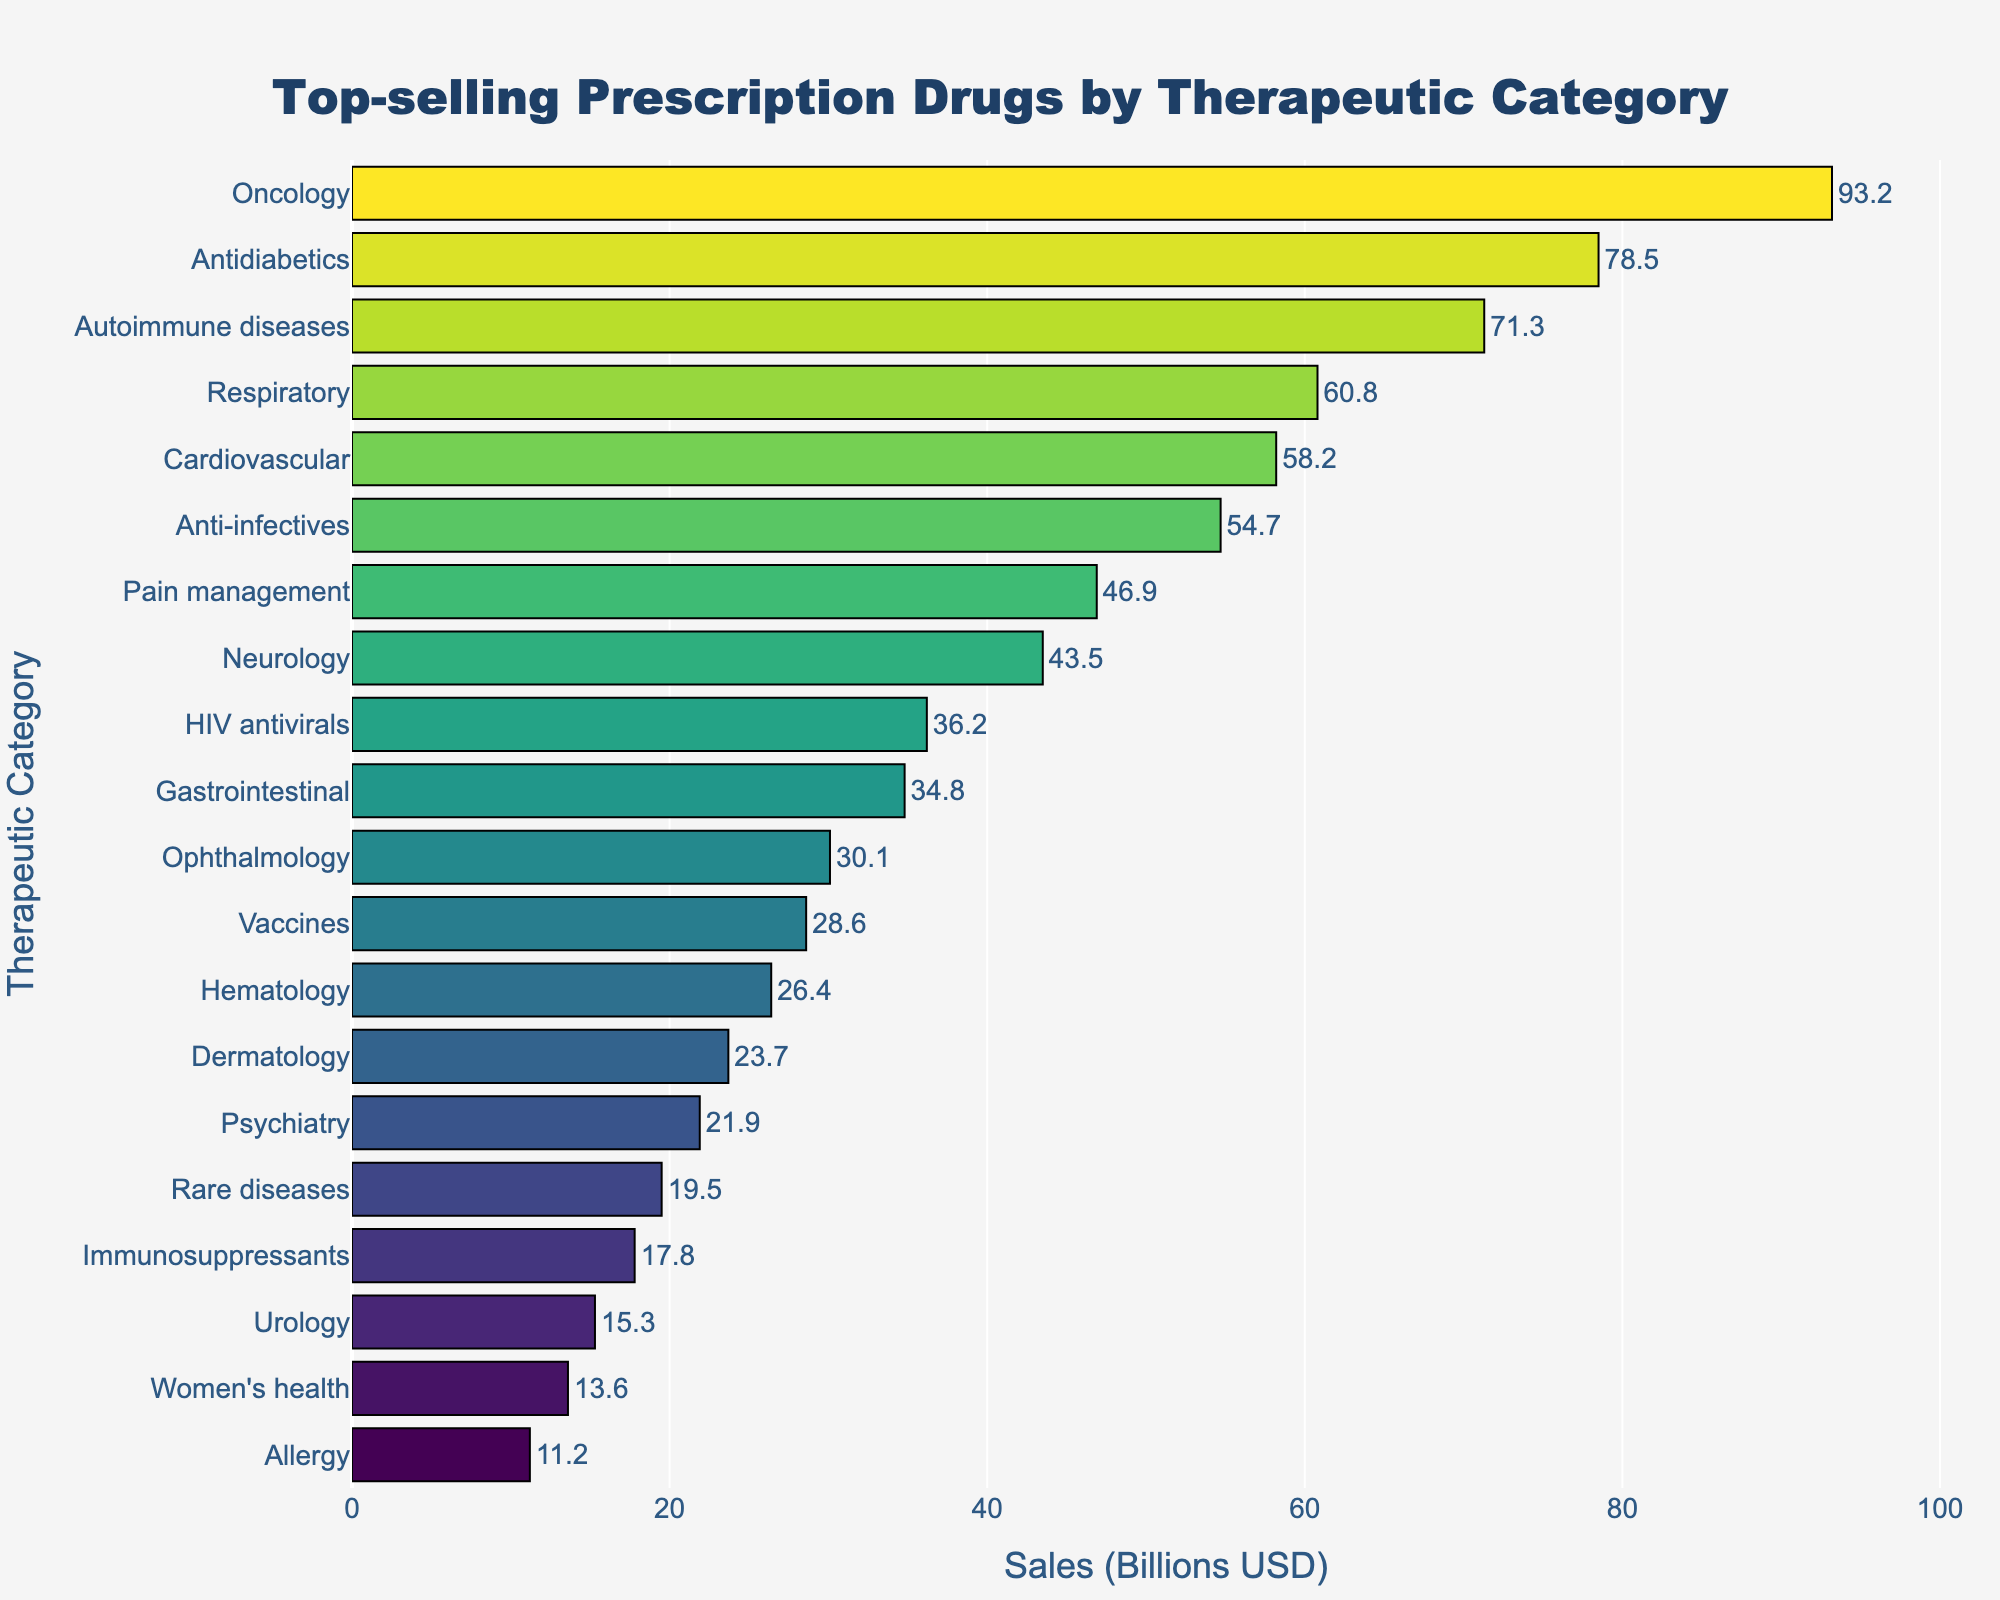Which therapeutic category has the highest sales? The bar chart shows that the bar for Oncology is the longest, indicating it has the highest sales among all categories.
Answer: Oncology Which therapeutic category has the lowest sales? The bar chart shows that Allergy has the shortest bar, indicating it has the lowest sales among all categories.
Answer: Allergy How much more are the sales for Oncology compared to Allergy? The sales for Oncology are 93.2 billion USD, and the sales for Allergy are 11.2 billion USD. The difference is 93.2 - 11.2 = 82 billion USD.
Answer: 82 billion USD What is the average sales of the top three therapeutic categories? The top three categories by sales are Oncology (93.2), Antidiabetics (78.5), and Autoimmune diseases (71.3). The average is (93.2 + 78.5 + 71.3) / 3 = 81.0 billion USD.
Answer: 81.0 billion USD Are the sales for Neurology higher than for Gastrointestinal? The bar for Neurology is longer than for Gastrointestinal, indicating that sales for Neurology (43.5 billion USD) are higher than for Gastrointestinal (34.8 billion USD).
Answer: Yes What is the sales range among all the therapeutic categories? The highest sales are for Oncology at 93.2 billion USD, and the lowest sales are for Allergy at 11.2 billion USD. The range is 93.2 - 11.2 = 82 billion USD.
Answer: 82 billion USD Which categories have sales above 50 billion USD? The categories with sales above 50 billion USD are Oncology (93.2), Antidiabetics (78.5), Autoimmune diseases (71.3), Respiratory (60.8), and Cardiovascular (58.2).
Answer: Oncology, Antidiabetics, Autoimmune diseases, Respiratory, Cardiovascular What is the combined sales for Cardiovascular and Neurology? The sales for Cardiovascular are 58.2 billion USD, and for Neurology, it is 43.5 billion USD. The combined sales are 58.2 + 43.5 = 101.7 billion USD.
Answer: 101.7 billion USD Which therapeutic category has slightly higher sales: Pain management or Neurology? The bar for Pain management is slightly longer than Neurology, indicating that Pain management (46.9 billion USD) has slightly higher sales than Neurology (43.5 billion USD).
Answer: Pain management 